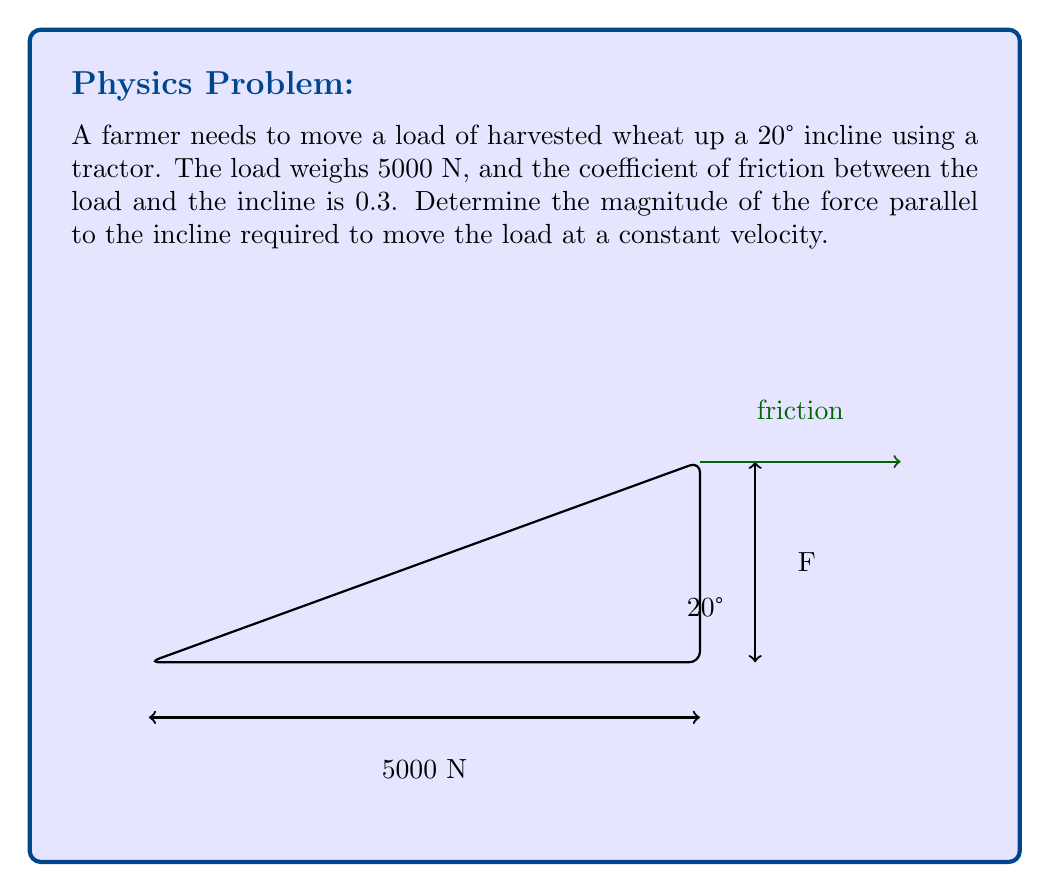Teach me how to tackle this problem. To solve this problem, we need to consider the forces acting on the load and use vector addition. Let's break it down step-by-step:

1) Identify the forces:
   - Weight of the load (W): 5000 N (downward)
   - Normal force (N): perpendicular to the incline
   - Friction force (f): parallel to the incline, opposing motion
   - Applied force (F): parallel to the incline, in the direction of motion

2) Resolve the weight vector into components:
   - Parallel to the incline: $W_\parallel = W \sin 20°$
   - Perpendicular to the incline: $W_\perp = W \cos 20°$

3) Calculate the normal force:
   $N = W_\perp = 5000 \cos 20° = 4698.4$ N

4) Calculate the friction force:
   $f = \mu N = 0.3 \times 4698.4 = 1409.5$ N

5) For constant velocity, the net force must be zero. Therefore, the applied force must equal the sum of the friction force and the component of weight parallel to the incline:

   $F = f + W_\parallel$

6) Calculate $W_\parallel$:
   $W_\parallel = 5000 \sin 20° = 1710.1$ N

7) Sum the forces:
   $F = 1409.5 + 1710.1 = 3119.6$ N

Therefore, the magnitude of the force required to move the load at constant velocity is approximately 3119.6 N.
Answer: $F = 3119.6$ N 